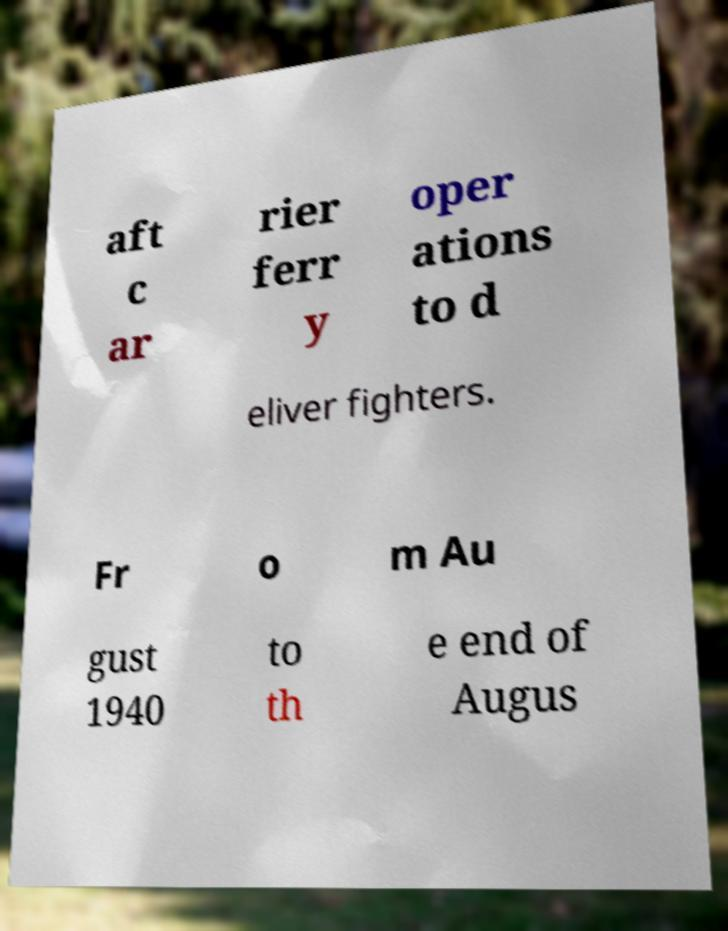Could you assist in decoding the text presented in this image and type it out clearly? aft c ar rier ferr y oper ations to d eliver fighters. Fr o m Au gust 1940 to th e end of Augus 